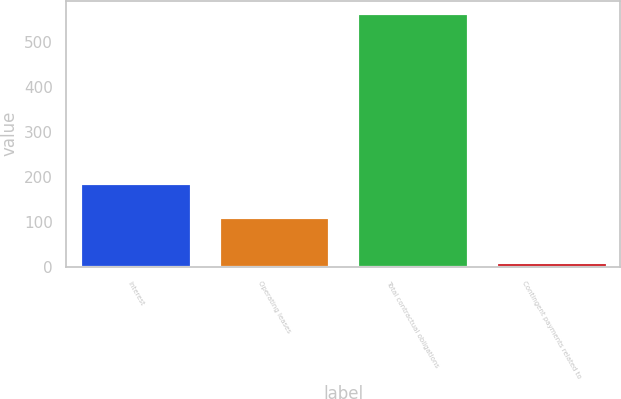Convert chart. <chart><loc_0><loc_0><loc_500><loc_500><bar_chart><fcel>Interest<fcel>Operating leases<fcel>Total contractual obligations<fcel>Contingent payments related to<nl><fcel>186<fcel>111<fcel>564<fcel>10<nl></chart> 